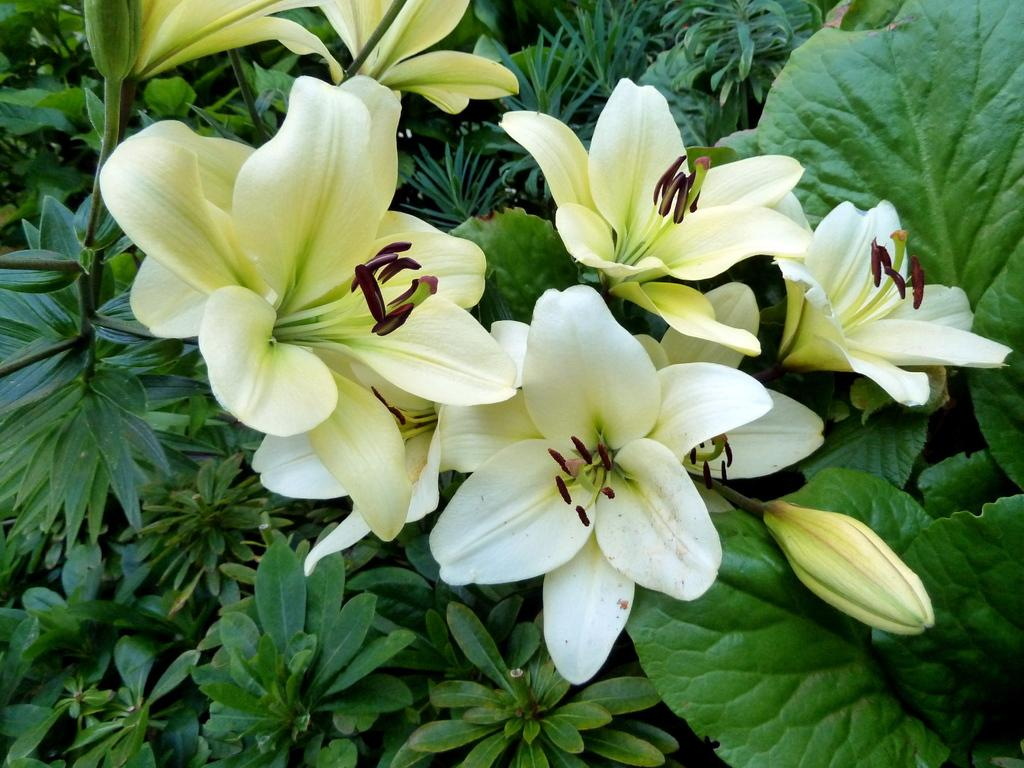What type of flowers can be seen in the image? There are white colored flowers in the image. Where are the flowers located? The flowers are on plants. What color are the leaves of the plants? The leaves of the plants have a green color. Are there any plants with green leaves visible in the background of the image? Yes, there are plants with green color leaves in the background of the image. How many bits can be seen in the image? There are no bits present in the image. 